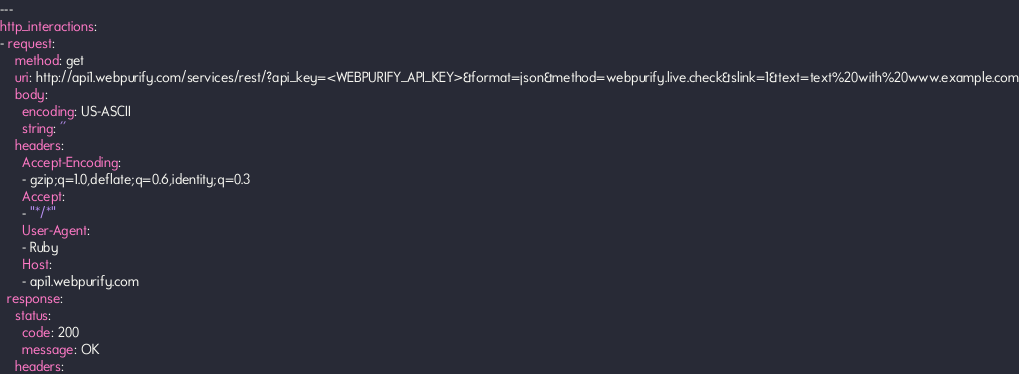Convert code to text. <code><loc_0><loc_0><loc_500><loc_500><_YAML_>---
http_interactions:
- request:
    method: get
    uri: http://api1.webpurify.com/services/rest/?api_key=<WEBPURIFY_API_KEY>&format=json&method=webpurify.live.check&slink=1&text=text%20with%20www.example.com
    body:
      encoding: US-ASCII
      string: ''
    headers:
      Accept-Encoding:
      - gzip;q=1.0,deflate;q=0.6,identity;q=0.3
      Accept:
      - "*/*"
      User-Agent:
      - Ruby
      Host:
      - api1.webpurify.com
  response:
    status:
      code: 200
      message: OK
    headers:</code> 